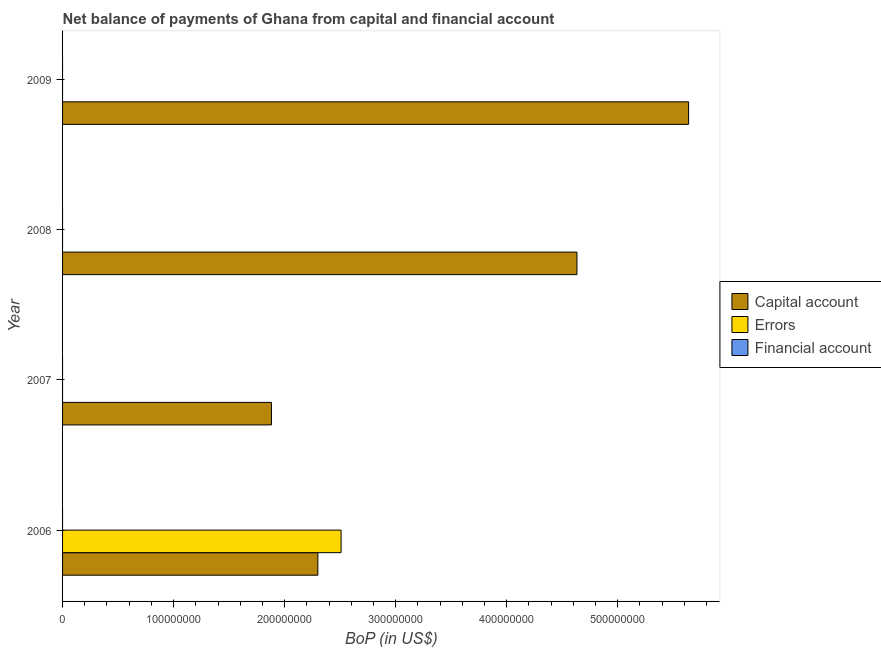Are the number of bars per tick equal to the number of legend labels?
Keep it short and to the point. No. Are the number of bars on each tick of the Y-axis equal?
Provide a succinct answer. No. How many bars are there on the 3rd tick from the top?
Offer a very short reply. 1. How many bars are there on the 1st tick from the bottom?
Your response must be concise. 2. What is the amount of net capital account in 2009?
Ensure brevity in your answer.  5.64e+08. Across all years, what is the maximum amount of errors?
Offer a very short reply. 2.51e+08. What is the total amount of net capital account in the graph?
Your response must be concise. 1.45e+09. What is the difference between the amount of net capital account in 2006 and that in 2009?
Offer a very short reply. -3.34e+08. What is the difference between the amount of errors in 2006 and the amount of net capital account in 2008?
Provide a short and direct response. -2.12e+08. What is the average amount of financial account per year?
Offer a very short reply. 0. What is the ratio of the amount of net capital account in 2007 to that in 2008?
Provide a succinct answer. 0.41. Is the amount of net capital account in 2008 less than that in 2009?
Provide a short and direct response. Yes. What is the difference between the highest and the lowest amount of net capital account?
Offer a terse response. 3.76e+08. How many years are there in the graph?
Offer a terse response. 4. Are the values on the major ticks of X-axis written in scientific E-notation?
Your response must be concise. No. Does the graph contain any zero values?
Make the answer very short. Yes. Does the graph contain grids?
Provide a short and direct response. No. Where does the legend appear in the graph?
Ensure brevity in your answer.  Center right. How many legend labels are there?
Ensure brevity in your answer.  3. How are the legend labels stacked?
Your response must be concise. Vertical. What is the title of the graph?
Your answer should be compact. Net balance of payments of Ghana from capital and financial account. Does "Capital account" appear as one of the legend labels in the graph?
Your response must be concise. Yes. What is the label or title of the X-axis?
Offer a very short reply. BoP (in US$). What is the BoP (in US$) in Capital account in 2006?
Your answer should be very brief. 2.30e+08. What is the BoP (in US$) of Errors in 2006?
Give a very brief answer. 2.51e+08. What is the BoP (in US$) of Capital account in 2007?
Give a very brief answer. 1.88e+08. What is the BoP (in US$) in Errors in 2007?
Offer a terse response. 0. What is the BoP (in US$) of Capital account in 2008?
Provide a short and direct response. 4.63e+08. What is the BoP (in US$) of Financial account in 2008?
Your answer should be very brief. 0. What is the BoP (in US$) of Capital account in 2009?
Your answer should be compact. 5.64e+08. What is the BoP (in US$) of Errors in 2009?
Your response must be concise. 0. What is the BoP (in US$) of Financial account in 2009?
Your response must be concise. 0. Across all years, what is the maximum BoP (in US$) in Capital account?
Keep it short and to the point. 5.64e+08. Across all years, what is the maximum BoP (in US$) of Errors?
Keep it short and to the point. 2.51e+08. Across all years, what is the minimum BoP (in US$) of Capital account?
Your response must be concise. 1.88e+08. Across all years, what is the minimum BoP (in US$) of Errors?
Give a very brief answer. 0. What is the total BoP (in US$) in Capital account in the graph?
Your answer should be very brief. 1.45e+09. What is the total BoP (in US$) of Errors in the graph?
Your response must be concise. 2.51e+08. What is the difference between the BoP (in US$) in Capital account in 2006 and that in 2007?
Offer a very short reply. 4.18e+07. What is the difference between the BoP (in US$) of Capital account in 2006 and that in 2008?
Give a very brief answer. -2.33e+08. What is the difference between the BoP (in US$) in Capital account in 2006 and that in 2009?
Your answer should be compact. -3.34e+08. What is the difference between the BoP (in US$) in Capital account in 2007 and that in 2008?
Your response must be concise. -2.75e+08. What is the difference between the BoP (in US$) in Capital account in 2007 and that in 2009?
Keep it short and to the point. -3.76e+08. What is the difference between the BoP (in US$) in Capital account in 2008 and that in 2009?
Offer a terse response. -1.01e+08. What is the average BoP (in US$) in Capital account per year?
Give a very brief answer. 3.61e+08. What is the average BoP (in US$) in Errors per year?
Keep it short and to the point. 6.27e+07. What is the average BoP (in US$) in Financial account per year?
Give a very brief answer. 0. In the year 2006, what is the difference between the BoP (in US$) of Capital account and BoP (in US$) of Errors?
Ensure brevity in your answer.  -2.09e+07. What is the ratio of the BoP (in US$) in Capital account in 2006 to that in 2007?
Your answer should be very brief. 1.22. What is the ratio of the BoP (in US$) of Capital account in 2006 to that in 2008?
Your response must be concise. 0.5. What is the ratio of the BoP (in US$) of Capital account in 2006 to that in 2009?
Ensure brevity in your answer.  0.41. What is the ratio of the BoP (in US$) of Capital account in 2007 to that in 2008?
Your answer should be compact. 0.41. What is the ratio of the BoP (in US$) in Capital account in 2007 to that in 2009?
Make the answer very short. 0.33. What is the ratio of the BoP (in US$) in Capital account in 2008 to that in 2009?
Keep it short and to the point. 0.82. What is the difference between the highest and the second highest BoP (in US$) in Capital account?
Your response must be concise. 1.01e+08. What is the difference between the highest and the lowest BoP (in US$) of Capital account?
Provide a succinct answer. 3.76e+08. What is the difference between the highest and the lowest BoP (in US$) in Errors?
Keep it short and to the point. 2.51e+08. 